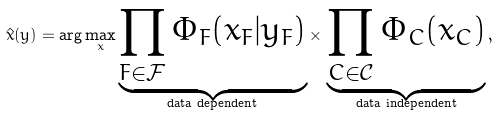Convert formula to latex. <formula><loc_0><loc_0><loc_500><loc_500>\hat { x } ( y ) = \arg \max _ { x } \underbrace { \prod _ { F \in \mathcal { F } } \Phi _ { F } ( x _ { F } | y _ { F } ) } _ { \text {data dependent} } \times \, \underbrace { \prod _ { C \in \mathcal { C } } \Phi _ { C } ( x _ { C } ) } _ { \text {data independent} } \, ,</formula> 